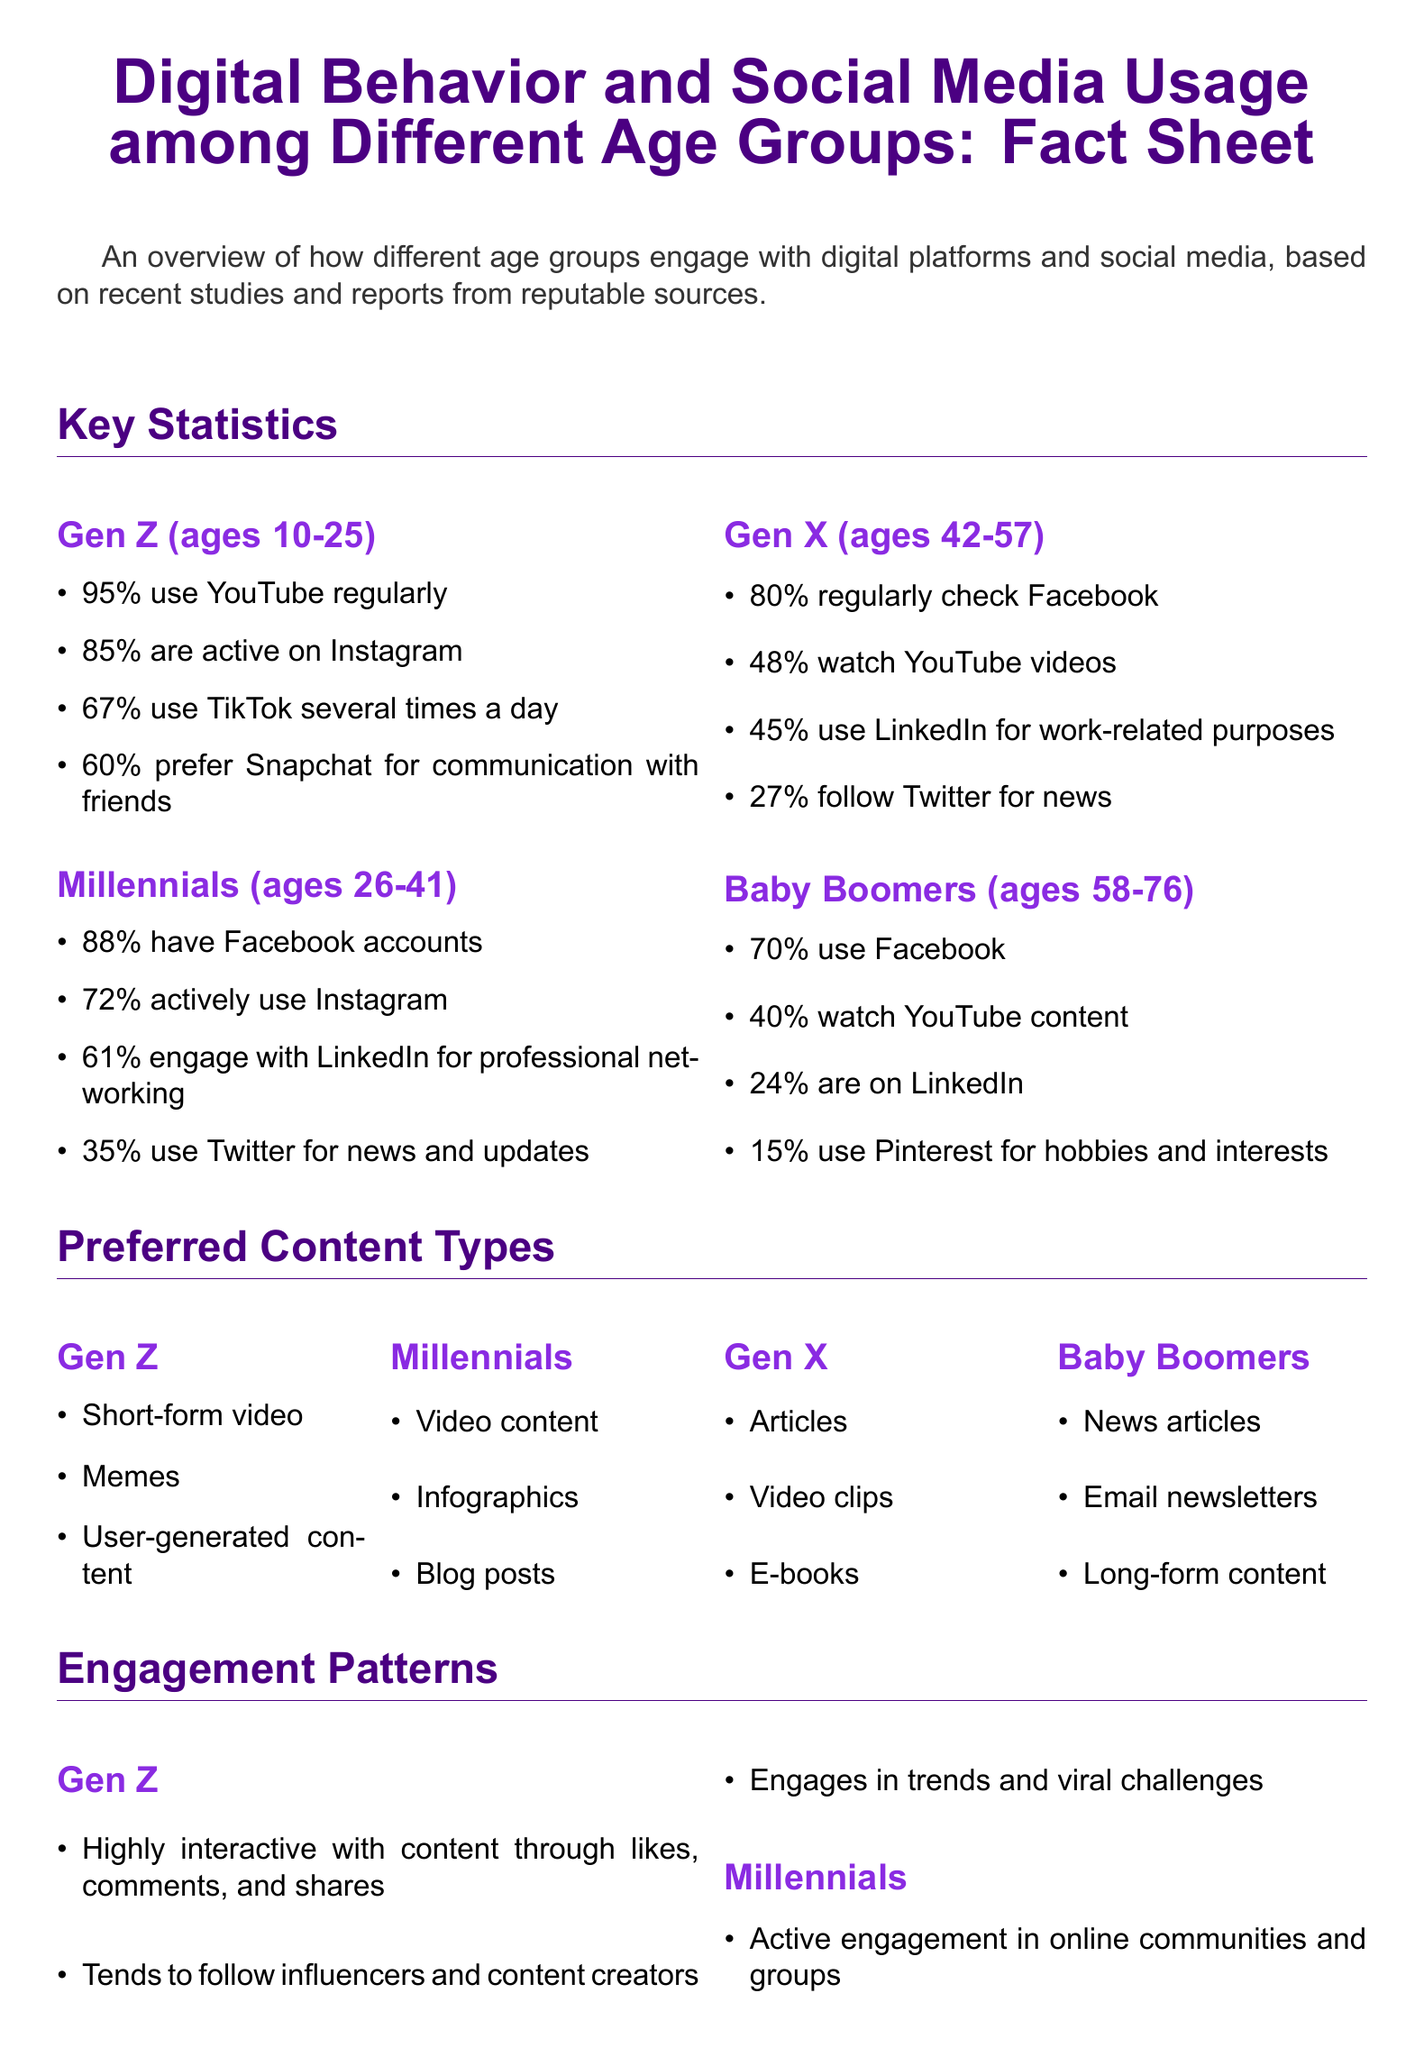what percentage of Gen Z uses YouTube regularly? The document states that 95% of Gen Z uses YouTube regularly.
Answer: 95% what is the most preferred content type for Baby Boomers? The document lists news articles as a preferred content type for Baby Boomers.
Answer: News articles which age group has the lowest usage of Instagram? The document indicates that Baby Boomers have the lowest Instagram usage at 15%.
Answer: 15% how many Millennials engage with LinkedIn for professional networking? The document states that 61% of Millennials engage with LinkedIn for professional networking.
Answer: 61% what type of content do Gen X individuals prefer primarily? According to the document, Gen X individuals primarily prefer articles.
Answer: Articles which age group is the least likely to engage in commenting or sharing? The document mentions that Baby Boomers are the least likely to engage in commenting or sharing.
Answer: Baby Boomers how does Gen Z typically engage with content? The document describes Gen Z as highly interactive with content.
Answer: Highly interactive what is the engagement pattern characteristic of Millennials? The document notes that Millennials are frequent reviewers and sharers of personal experiences.
Answer: Frequent reviewers which source does the document list for its statistics? The document lists Pew Research Center as one of the sources for its statistics.
Answer: Pew Research Center 